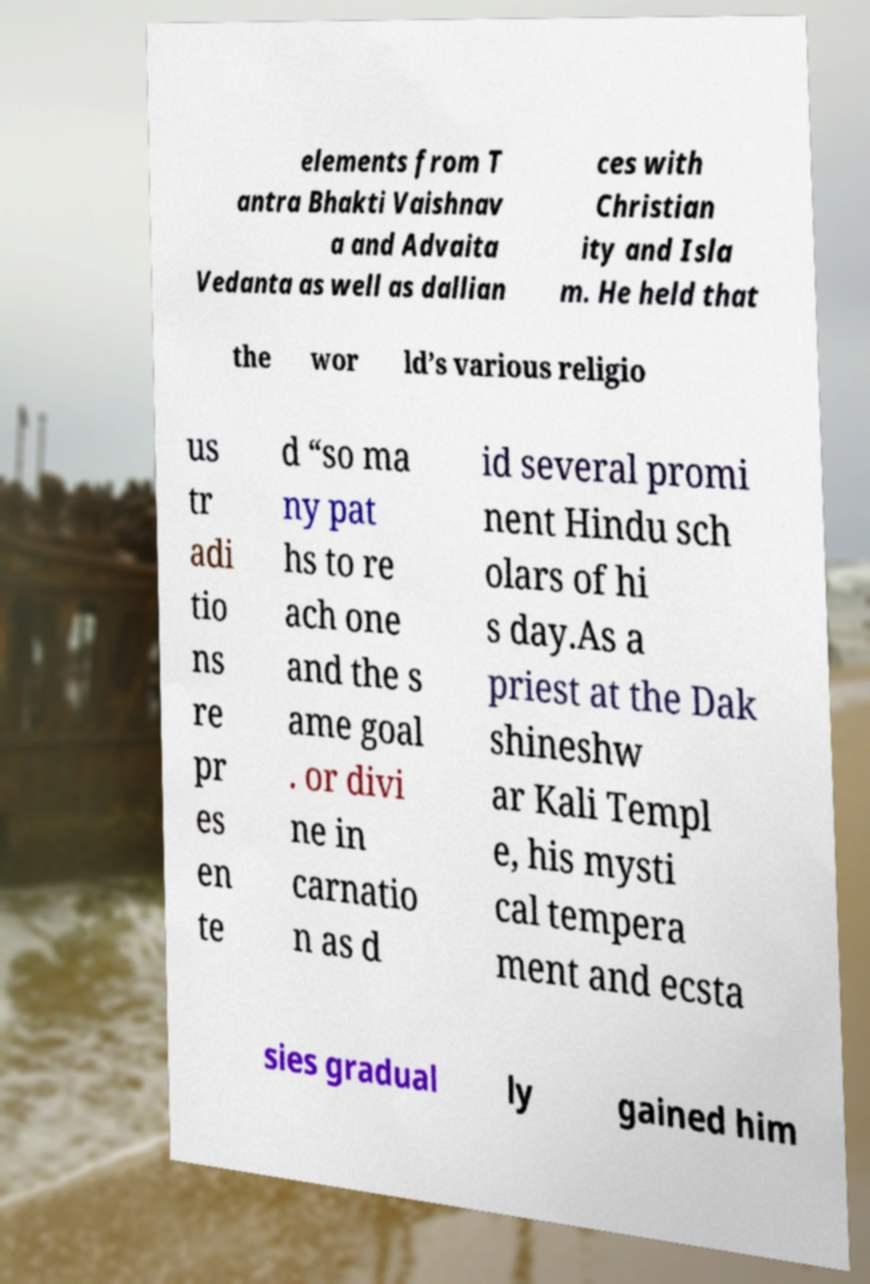Could you extract and type out the text from this image? elements from T antra Bhakti Vaishnav a and Advaita Vedanta as well as dallian ces with Christian ity and Isla m. He held that the wor ld’s various religio us tr adi tio ns re pr es en te d “so ma ny pat hs to re ach one and the s ame goal . or divi ne in carnatio n as d id several promi nent Hindu sch olars of hi s day.As a priest at the Dak shineshw ar Kali Templ e, his mysti cal tempera ment and ecsta sies gradual ly gained him 